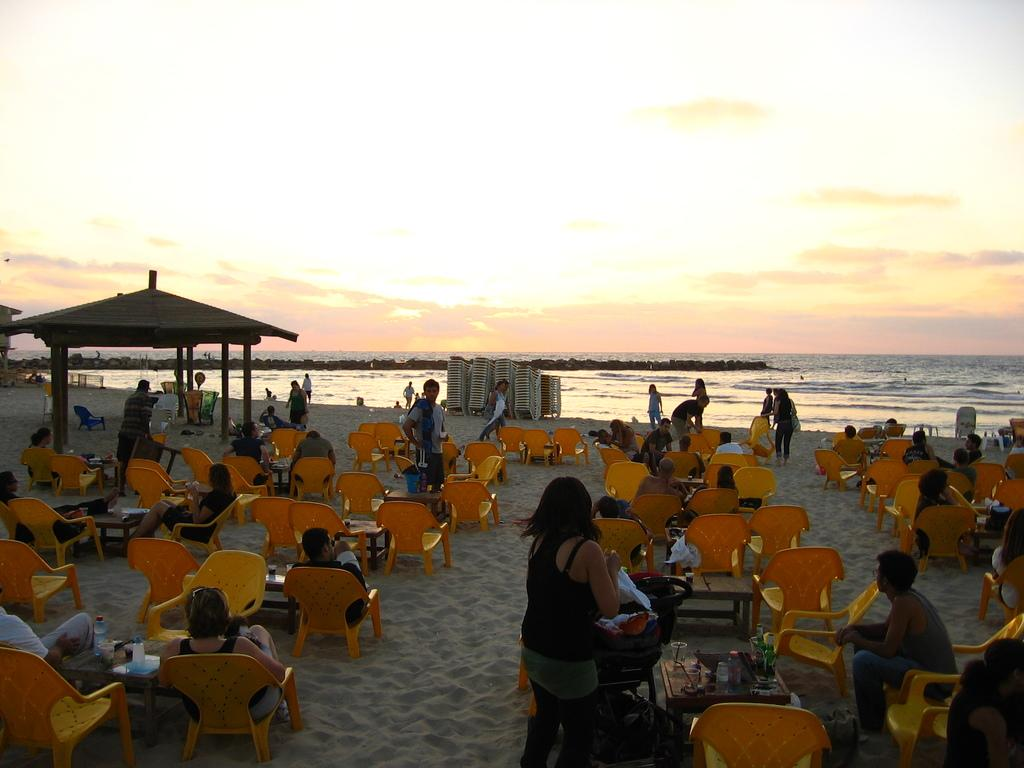What are the persons in the image doing? The persons in the image are sitting on chairs and standing on the sand. What type of terrain is visible in the image? There is sand visible in the image. What type of structure can be seen in the image? There is a hut in the image. What else is visible in the image besides the sand and hut? There is water visible in the image, as well as the sky. What company is responsible for the account of the persons in the image? There is no information about a company or account in the image; it simply shows persons sitting and standing in a sandy environment with a hut and water nearby. 